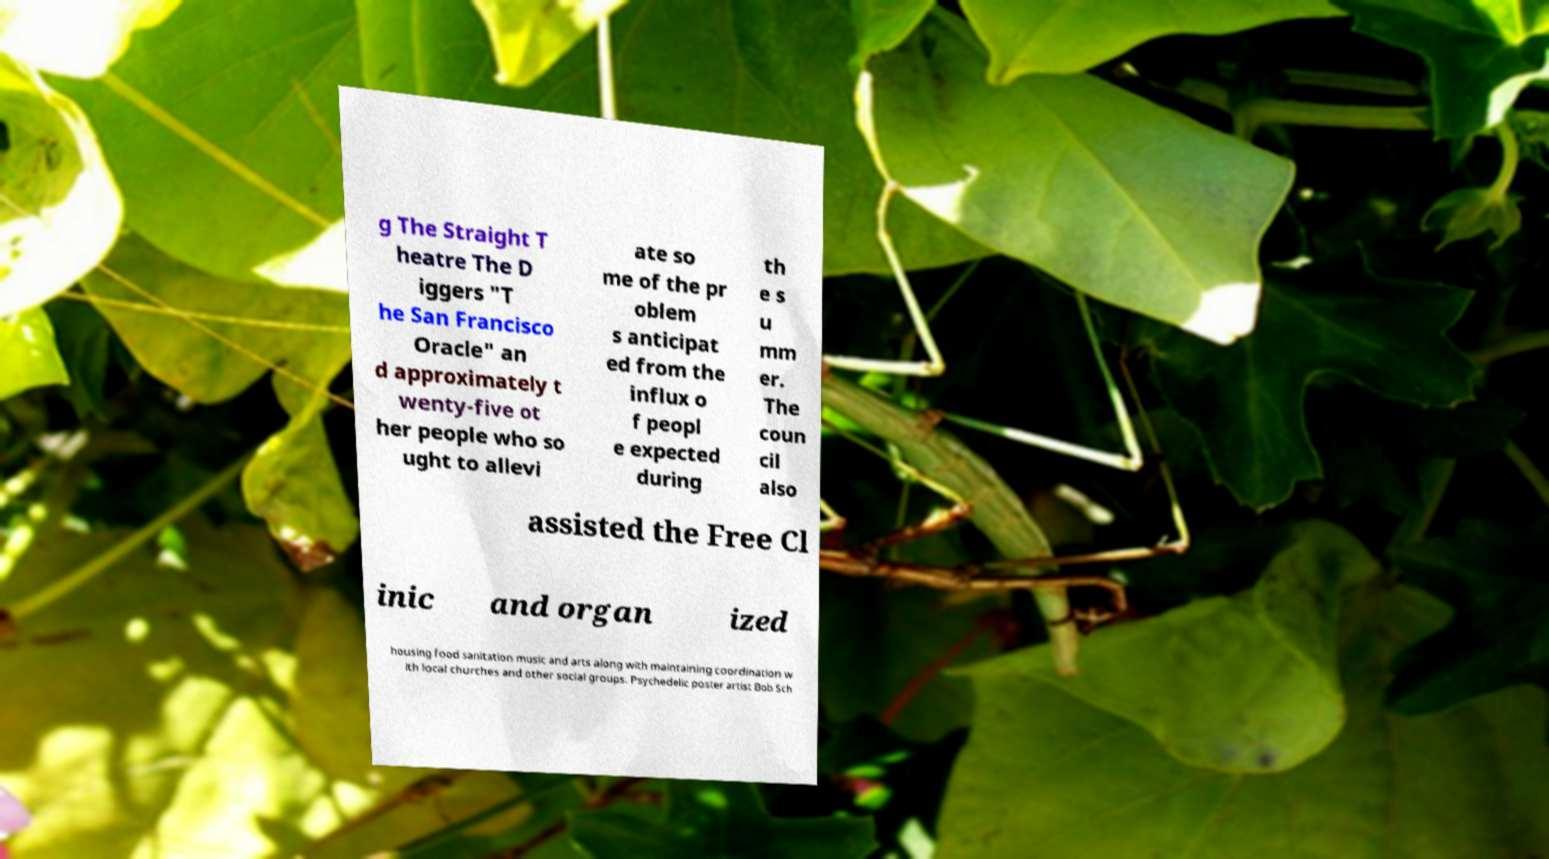There's text embedded in this image that I need extracted. Can you transcribe it verbatim? g The Straight T heatre The D iggers "T he San Francisco Oracle" an d approximately t wenty-five ot her people who so ught to allevi ate so me of the pr oblem s anticipat ed from the influx o f peopl e expected during th e s u mm er. The coun cil also assisted the Free Cl inic and organ ized housing food sanitation music and arts along with maintaining coordination w ith local churches and other social groups. Psychedelic poster artist Bob Sch 